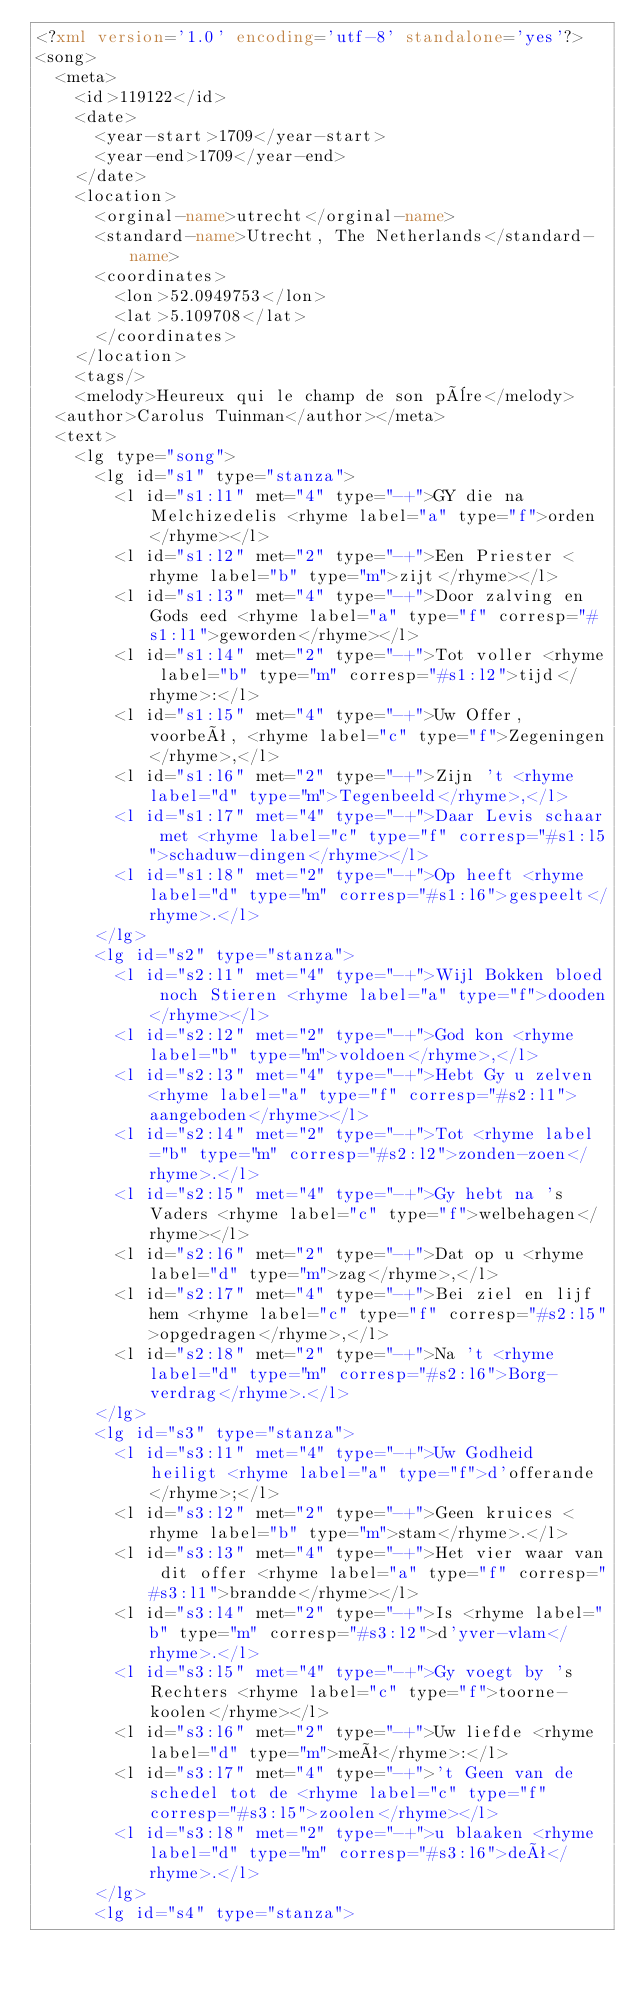<code> <loc_0><loc_0><loc_500><loc_500><_XML_><?xml version='1.0' encoding='utf-8' standalone='yes'?>
<song>
  <meta>
    <id>119122</id>
    <date>
      <year-start>1709</year-start>
      <year-end>1709</year-end>
    </date>
    <location>
      <orginal-name>utrecht</orginal-name>
      <standard-name>Utrecht, The Netherlands</standard-name>
      <coordinates>
        <lon>52.0949753</lon>
        <lat>5.109708</lat>
      </coordinates>
    </location>
    <tags/>
    <melody>Heureux qui le champ de son père</melody>
  <author>Carolus Tuinman</author></meta>
  <text>
    <lg type="song">
      <lg id="s1" type="stanza">
        <l id="s1:l1" met="4" type="-+">GY die na Melchizedelis <rhyme label="a" type="f">orden</rhyme></l>
        <l id="s1:l2" met="2" type="-+">Een Priester <rhyme label="b" type="m">zijt</rhyme></l>
        <l id="s1:l3" met="4" type="-+">Door zalving en Gods eed <rhyme label="a" type="f" corresp="#s1:l1">geworden</rhyme></l>
        <l id="s1:l4" met="2" type="-+">Tot voller <rhyme label="b" type="m" corresp="#s1:l2">tijd</rhyme>:</l>
        <l id="s1:l5" met="4" type="-+">Uw Offer, voorbeê, <rhyme label="c" type="f">Zegeningen</rhyme>,</l>
        <l id="s1:l6" met="2" type="-+">Zijn 't <rhyme label="d" type="m">Tegenbeeld</rhyme>,</l>
        <l id="s1:l7" met="4" type="-+">Daar Levis schaar met <rhyme label="c" type="f" corresp="#s1:l5">schaduw-dingen</rhyme></l>
        <l id="s1:l8" met="2" type="-+">Op heeft <rhyme label="d" type="m" corresp="#s1:l6">gespeelt</rhyme>.</l>
      </lg>
      <lg id="s2" type="stanza">
        <l id="s2:l1" met="4" type="-+">Wijl Bokken bloed noch Stieren <rhyme label="a" type="f">dooden</rhyme></l>
        <l id="s2:l2" met="2" type="-+">God kon <rhyme label="b" type="m">voldoen</rhyme>,</l>
        <l id="s2:l3" met="4" type="-+">Hebt Gy u zelven <rhyme label="a" type="f" corresp="#s2:l1">aangeboden</rhyme></l>
        <l id="s2:l4" met="2" type="-+">Tot <rhyme label="b" type="m" corresp="#s2:l2">zonden-zoen</rhyme>.</l>
        <l id="s2:l5" met="4" type="-+">Gy hebt na 's Vaders <rhyme label="c" type="f">welbehagen</rhyme></l>
        <l id="s2:l6" met="2" type="-+">Dat op u <rhyme label="d" type="m">zag</rhyme>,</l>
        <l id="s2:l7" met="4" type="-+">Bei ziel en lijf hem <rhyme label="c" type="f" corresp="#s2:l5">opgedragen</rhyme>,</l>
        <l id="s2:l8" met="2" type="-+">Na 't <rhyme label="d" type="m" corresp="#s2:l6">Borg-verdrag</rhyme>.</l>
      </lg>
      <lg id="s3" type="stanza">
        <l id="s3:l1" met="4" type="-+">Uw Godheid heiligt <rhyme label="a" type="f">d'offerande</rhyme>;</l>
        <l id="s3:l2" met="2" type="-+">Geen kruices <rhyme label="b" type="m">stam</rhyme>.</l>
        <l id="s3:l3" met="4" type="-+">Het vier waar van dit offer <rhyme label="a" type="f" corresp="#s3:l1">brandde</rhyme></l>
        <l id="s3:l4" met="2" type="-+">Is <rhyme label="b" type="m" corresp="#s3:l2">d'yver-vlam</rhyme>.</l>
        <l id="s3:l5" met="4" type="-+">Gy voegt by 's Rechters <rhyme label="c" type="f">toorne-koolen</rhyme></l>
        <l id="s3:l6" met="2" type="-+">Uw liefde <rhyme label="d" type="m">meê</rhyme>:</l>
        <l id="s3:l7" met="4" type="-+">'t Geen van de schedel tot de <rhyme label="c" type="f" corresp="#s3:l5">zoolen</rhyme></l>
        <l id="s3:l8" met="2" type="-+">u blaaken <rhyme label="d" type="m" corresp="#s3:l6">deê</rhyme>.</l>
      </lg>
      <lg id="s4" type="stanza"></code> 